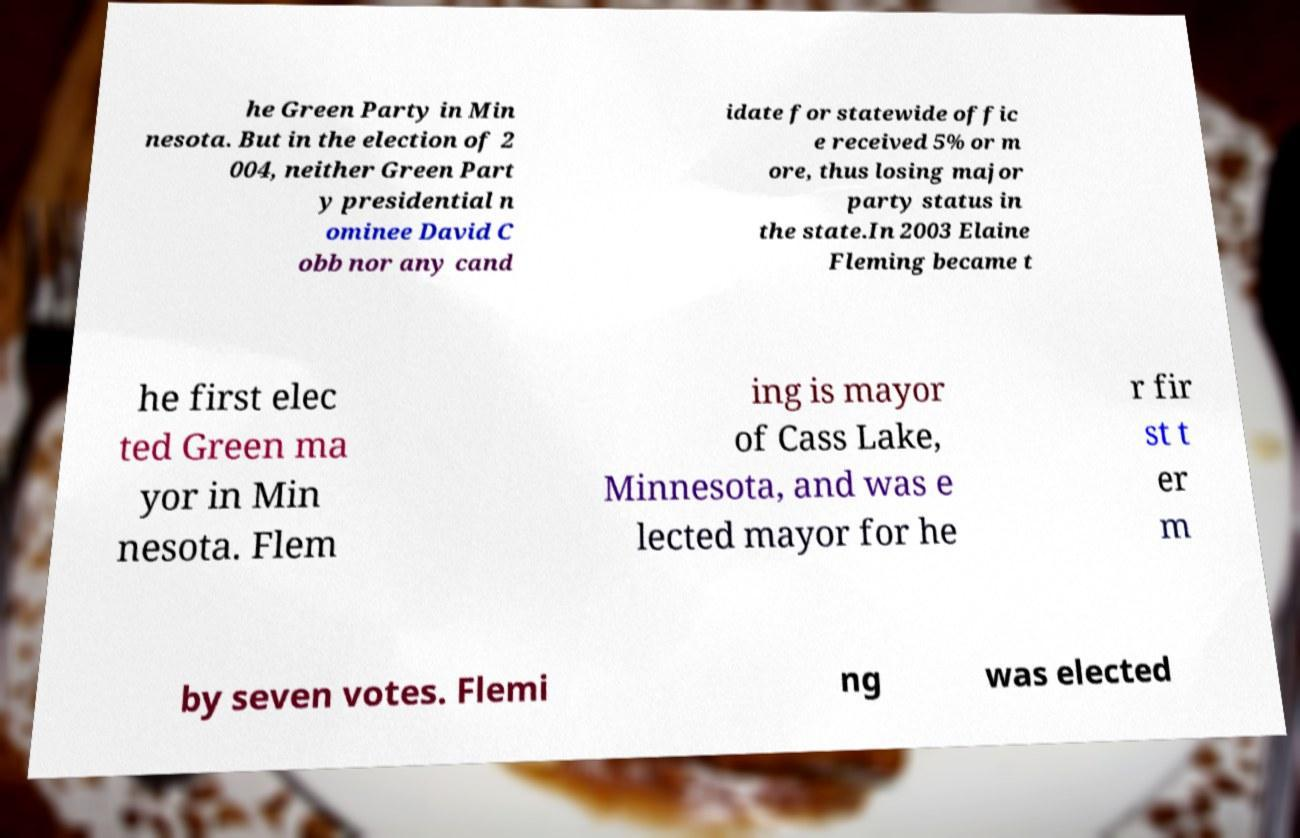For documentation purposes, I need the text within this image transcribed. Could you provide that? he Green Party in Min nesota. But in the election of 2 004, neither Green Part y presidential n ominee David C obb nor any cand idate for statewide offic e received 5% or m ore, thus losing major party status in the state.In 2003 Elaine Fleming became t he first elec ted Green ma yor in Min nesota. Flem ing is mayor of Cass Lake, Minnesota, and was e lected mayor for he r fir st t er m by seven votes. Flemi ng was elected 